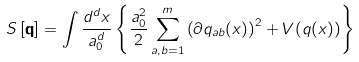Convert formula to latex. <formula><loc_0><loc_0><loc_500><loc_500>S \left [ \mathbf q \right ] = \int \frac { d ^ { d } x } { a _ { 0 } ^ { d } } \left \{ \frac { a _ { 0 } ^ { 2 } } { 2 } \sum _ { a , b = 1 } ^ { m } \left ( \partial q _ { a b } ( x ) \right ) ^ { 2 } + V ( q ( x ) ) \right \}</formula> 